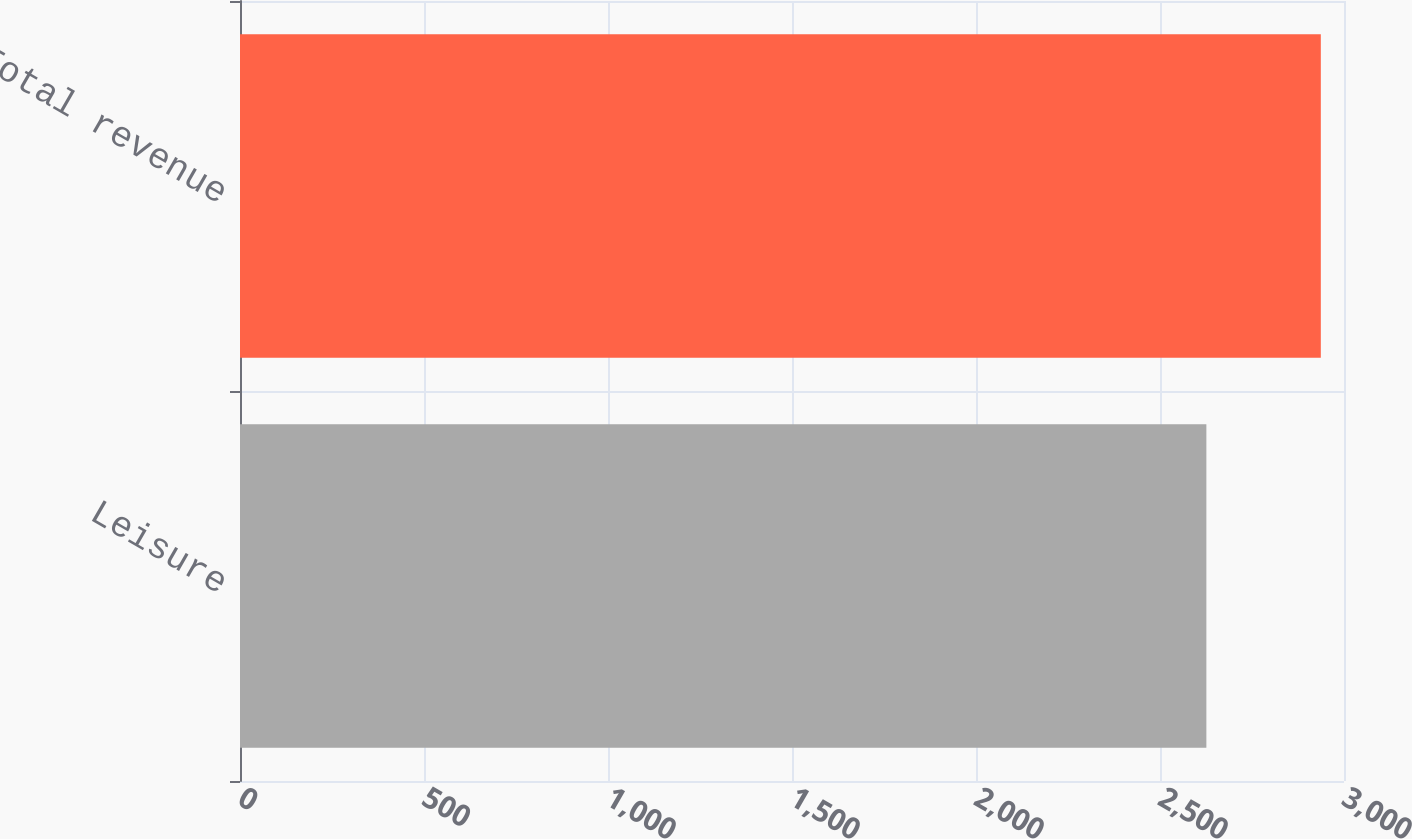Convert chart to OTSL. <chart><loc_0><loc_0><loc_500><loc_500><bar_chart><fcel>Leisure<fcel>Total revenue<nl><fcel>2626<fcel>2937<nl></chart> 